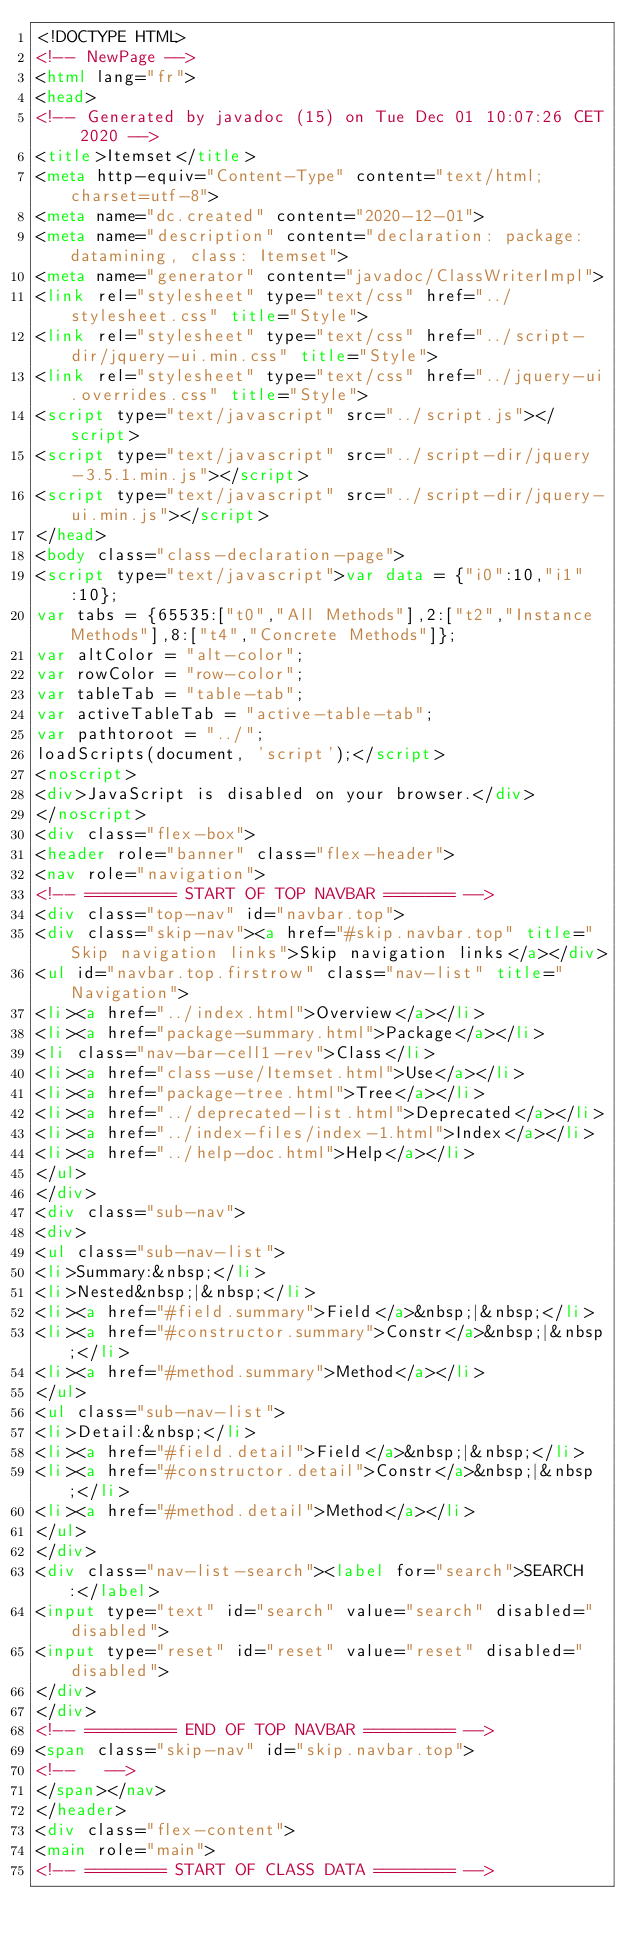<code> <loc_0><loc_0><loc_500><loc_500><_HTML_><!DOCTYPE HTML>
<!-- NewPage -->
<html lang="fr">
<head>
<!-- Generated by javadoc (15) on Tue Dec 01 10:07:26 CET 2020 -->
<title>Itemset</title>
<meta http-equiv="Content-Type" content="text/html; charset=utf-8">
<meta name="dc.created" content="2020-12-01">
<meta name="description" content="declaration: package: datamining, class: Itemset">
<meta name="generator" content="javadoc/ClassWriterImpl">
<link rel="stylesheet" type="text/css" href="../stylesheet.css" title="Style">
<link rel="stylesheet" type="text/css" href="../script-dir/jquery-ui.min.css" title="Style">
<link rel="stylesheet" type="text/css" href="../jquery-ui.overrides.css" title="Style">
<script type="text/javascript" src="../script.js"></script>
<script type="text/javascript" src="../script-dir/jquery-3.5.1.min.js"></script>
<script type="text/javascript" src="../script-dir/jquery-ui.min.js"></script>
</head>
<body class="class-declaration-page">
<script type="text/javascript">var data = {"i0":10,"i1":10};
var tabs = {65535:["t0","All Methods"],2:["t2","Instance Methods"],8:["t4","Concrete Methods"]};
var altColor = "alt-color";
var rowColor = "row-color";
var tableTab = "table-tab";
var activeTableTab = "active-table-tab";
var pathtoroot = "../";
loadScripts(document, 'script');</script>
<noscript>
<div>JavaScript is disabled on your browser.</div>
</noscript>
<div class="flex-box">
<header role="banner" class="flex-header">
<nav role="navigation">
<!-- ========= START OF TOP NAVBAR ======= -->
<div class="top-nav" id="navbar.top">
<div class="skip-nav"><a href="#skip.navbar.top" title="Skip navigation links">Skip navigation links</a></div>
<ul id="navbar.top.firstrow" class="nav-list" title="Navigation">
<li><a href="../index.html">Overview</a></li>
<li><a href="package-summary.html">Package</a></li>
<li class="nav-bar-cell1-rev">Class</li>
<li><a href="class-use/Itemset.html">Use</a></li>
<li><a href="package-tree.html">Tree</a></li>
<li><a href="../deprecated-list.html">Deprecated</a></li>
<li><a href="../index-files/index-1.html">Index</a></li>
<li><a href="../help-doc.html">Help</a></li>
</ul>
</div>
<div class="sub-nav">
<div>
<ul class="sub-nav-list">
<li>Summary:&nbsp;</li>
<li>Nested&nbsp;|&nbsp;</li>
<li><a href="#field.summary">Field</a>&nbsp;|&nbsp;</li>
<li><a href="#constructor.summary">Constr</a>&nbsp;|&nbsp;</li>
<li><a href="#method.summary">Method</a></li>
</ul>
<ul class="sub-nav-list">
<li>Detail:&nbsp;</li>
<li><a href="#field.detail">Field</a>&nbsp;|&nbsp;</li>
<li><a href="#constructor.detail">Constr</a>&nbsp;|&nbsp;</li>
<li><a href="#method.detail">Method</a></li>
</ul>
</div>
<div class="nav-list-search"><label for="search">SEARCH:</label>
<input type="text" id="search" value="search" disabled="disabled">
<input type="reset" id="reset" value="reset" disabled="disabled">
</div>
</div>
<!-- ========= END OF TOP NAVBAR ========= -->
<span class="skip-nav" id="skip.navbar.top">
<!--   -->
</span></nav>
</header>
<div class="flex-content">
<main role="main">
<!-- ======== START OF CLASS DATA ======== --></code> 